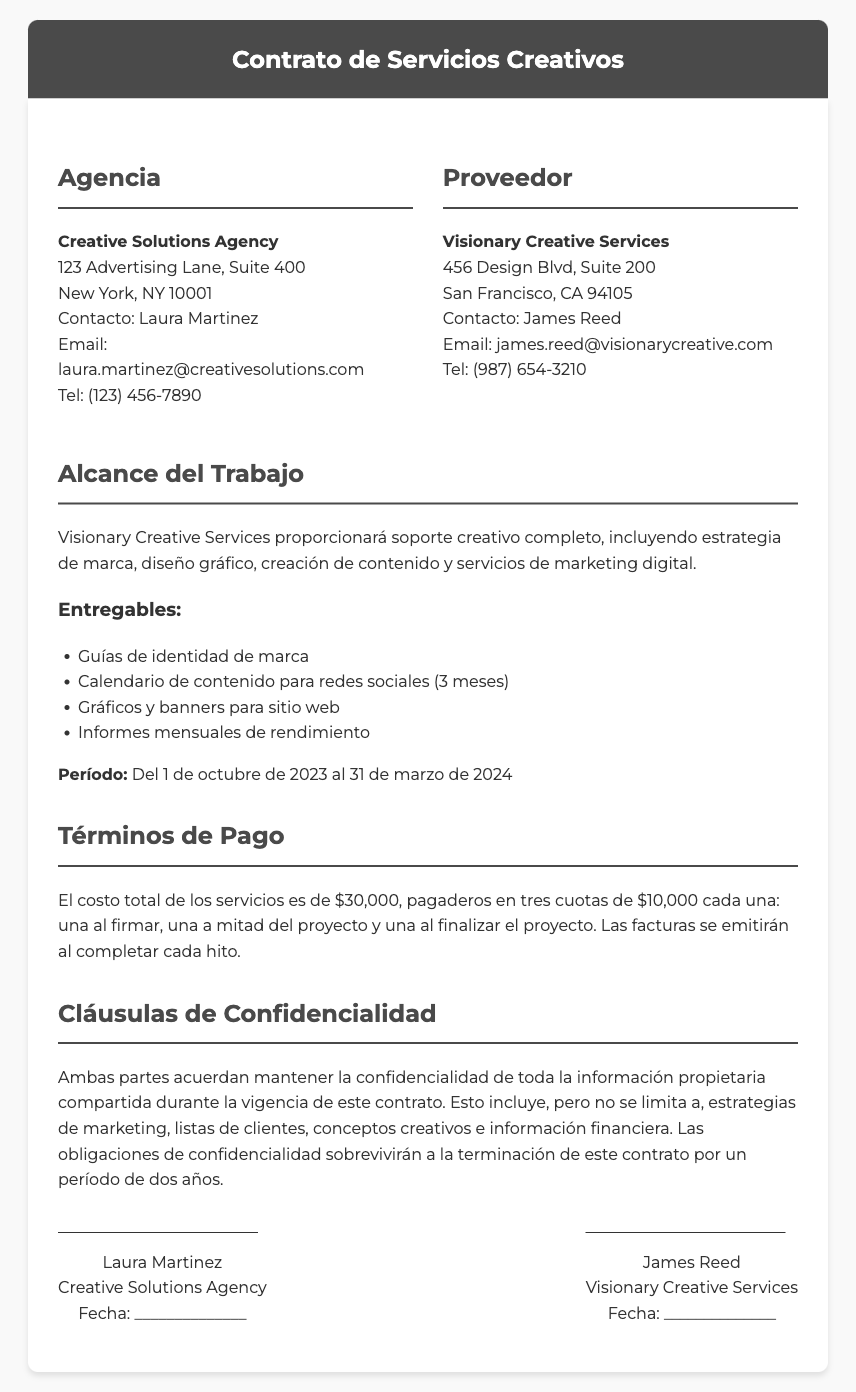¿Cuál es el costo total de los servicios? El costo total de los servicios es especificado en la sección de Términos de Pago.
Answer: $30,000 ¿Cuáles son los tres entregables principales? La sección "Entregables" lista varios, pero se pregunta por tres de ellos.
Answer: Guías de identidad de marca, Calendario de contenido para redes sociales, Gráficos y banners para sitio web ¿Cuándo inicia el período del contrato? La sección "Período" menciona el inicio de la vigencia del contrato.
Answer: 1 de octubre de 2023 ¿Cuántas cuotas se pagarán en total? La sección de Términos de Pago indica el número de cuotas.
Answer: Tres ¿Cuál es la duración de las obligaciones de confidencialidad? La cláusula de confidencialidad menciona el período durante el cual se deben mantener las obligaciones.
Answer: Dos años ¿Quién es la persona de contacto en la agencia? La sección de información de la agencia identifica al contacto.
Answer: Laura Martinez ¿Cuál es la dirección del proveedor? La sección de información del proveedor proporciona la dirección de la empresa.
Answer: 456 Design Blvd, Suite 200, San Francisco, CA 94105 ¿Cuándo se emiten las facturas? La sección de Términos de Pago explica cuándo se emitirán las facturas.
Answer: Al completar cada hito ¿Quién firma el contrato en representación de la agencia? La sección de firmas indica quién firmará por la agencia.
Answer: Laura Martinez 